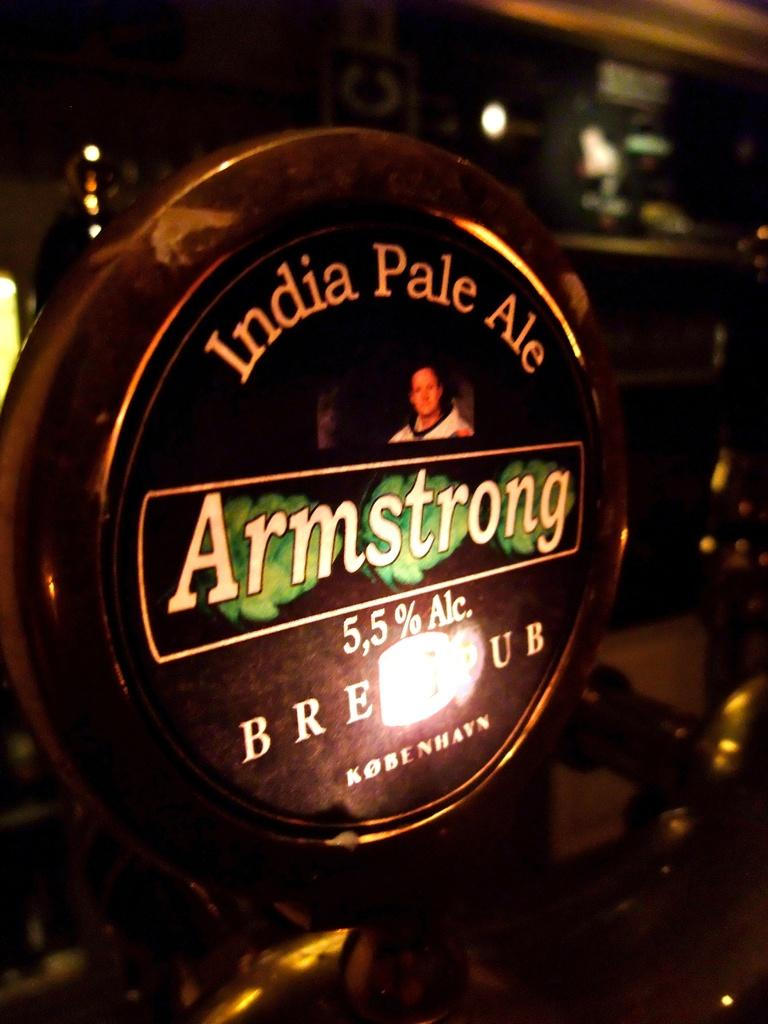What is the main object in the image? There is a name board in the image. What type of lighting is present in the image? Electric lights are visible in the image. How does the throat feel in the image? There is no mention of a throat in the image, so it cannot be determined how it feels. 